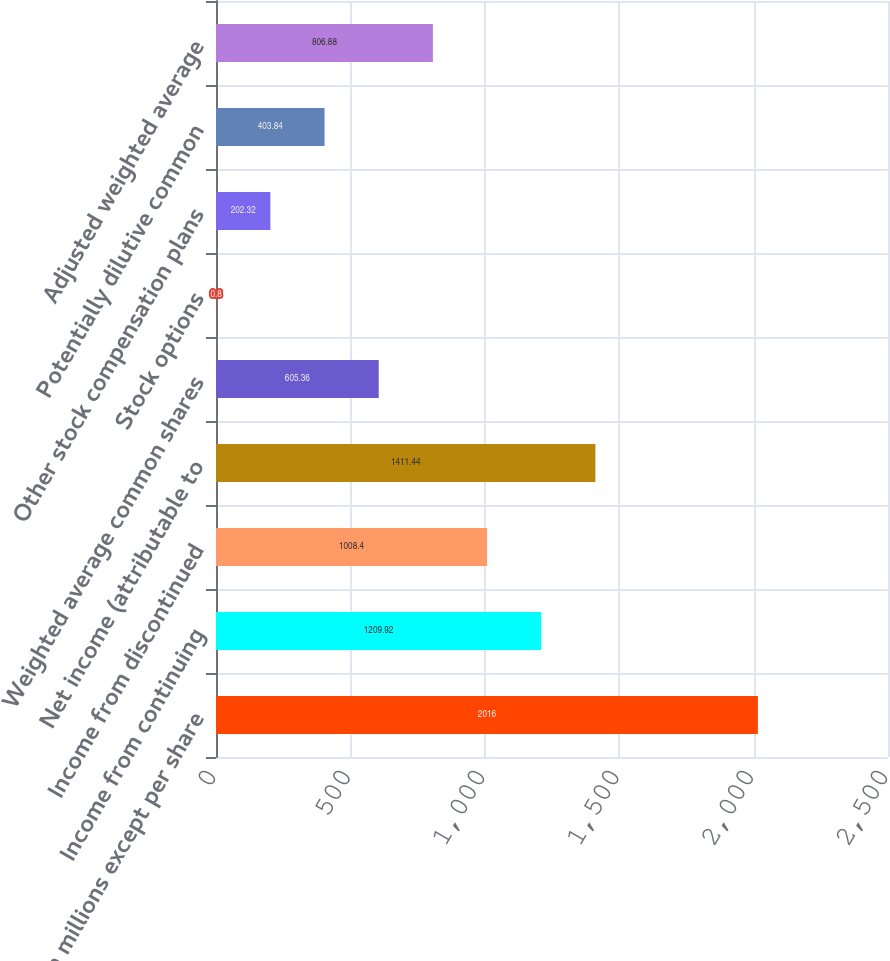<chart> <loc_0><loc_0><loc_500><loc_500><bar_chart><fcel>( in millions except per share<fcel>Income from continuing<fcel>Income from discontinued<fcel>Net income (attributable to<fcel>Weighted average common shares<fcel>Stock options<fcel>Other stock compensation plans<fcel>Potentially dilutive common<fcel>Adjusted weighted average<nl><fcel>2016<fcel>1209.92<fcel>1008.4<fcel>1411.44<fcel>605.36<fcel>0.8<fcel>202.32<fcel>403.84<fcel>806.88<nl></chart> 